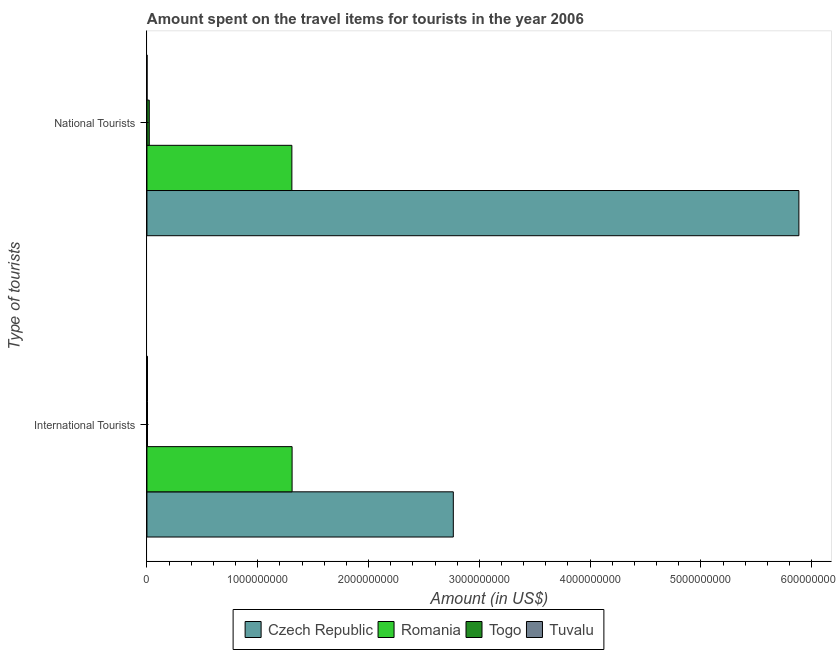How many different coloured bars are there?
Provide a short and direct response. 4. How many groups of bars are there?
Offer a very short reply. 2. What is the label of the 2nd group of bars from the top?
Offer a very short reply. International Tourists. What is the amount spent on travel items of international tourists in Czech Republic?
Provide a succinct answer. 2.76e+09. Across all countries, what is the maximum amount spent on travel items of national tourists?
Your answer should be very brief. 5.88e+09. Across all countries, what is the minimum amount spent on travel items of national tourists?
Give a very brief answer. 1.18e+06. In which country was the amount spent on travel items of national tourists maximum?
Make the answer very short. Czech Republic. In which country was the amount spent on travel items of national tourists minimum?
Provide a succinct answer. Tuvalu. What is the total amount spent on travel items of international tourists in the graph?
Your answer should be compact. 4.08e+09. What is the difference between the amount spent on travel items of national tourists in Tuvalu and that in Togo?
Your response must be concise. -1.98e+07. What is the difference between the amount spent on travel items of national tourists in Romania and the amount spent on travel items of international tourists in Czech Republic?
Provide a short and direct response. -1.46e+09. What is the average amount spent on travel items of national tourists per country?
Offer a terse response. 1.80e+09. What is the difference between the amount spent on travel items of international tourists and amount spent on travel items of national tourists in Togo?
Offer a very short reply. -1.60e+07. In how many countries, is the amount spent on travel items of national tourists greater than 200000000 US$?
Offer a terse response. 2. What is the ratio of the amount spent on travel items of national tourists in Czech Republic to that in Romania?
Make the answer very short. 4.5. Is the amount spent on travel items of national tourists in Togo less than that in Romania?
Keep it short and to the point. Yes. In how many countries, is the amount spent on travel items of international tourists greater than the average amount spent on travel items of international tourists taken over all countries?
Ensure brevity in your answer.  2. What does the 4th bar from the top in International Tourists represents?
Offer a terse response. Czech Republic. What does the 3rd bar from the bottom in National Tourists represents?
Provide a succinct answer. Togo. Are all the bars in the graph horizontal?
Your answer should be compact. Yes. Does the graph contain grids?
Provide a short and direct response. No. Where does the legend appear in the graph?
Your response must be concise. Bottom center. How many legend labels are there?
Your answer should be very brief. 4. What is the title of the graph?
Provide a succinct answer. Amount spent on the travel items for tourists in the year 2006. Does "Albania" appear as one of the legend labels in the graph?
Make the answer very short. No. What is the label or title of the Y-axis?
Offer a terse response. Type of tourists. What is the Amount (in US$) of Czech Republic in International Tourists?
Provide a short and direct response. 2.76e+09. What is the Amount (in US$) in Romania in International Tourists?
Provide a succinct answer. 1.31e+09. What is the Amount (in US$) of Tuvalu in International Tourists?
Provide a succinct answer. 4.96e+06. What is the Amount (in US$) of Czech Republic in National Tourists?
Your response must be concise. 5.88e+09. What is the Amount (in US$) of Romania in National Tourists?
Your answer should be compact. 1.31e+09. What is the Amount (in US$) in Togo in National Tourists?
Offer a very short reply. 2.10e+07. What is the Amount (in US$) of Tuvalu in National Tourists?
Provide a succinct answer. 1.18e+06. Across all Type of tourists, what is the maximum Amount (in US$) of Czech Republic?
Provide a short and direct response. 5.88e+09. Across all Type of tourists, what is the maximum Amount (in US$) in Romania?
Make the answer very short. 1.31e+09. Across all Type of tourists, what is the maximum Amount (in US$) of Togo?
Your response must be concise. 2.10e+07. Across all Type of tourists, what is the maximum Amount (in US$) of Tuvalu?
Offer a terse response. 4.96e+06. Across all Type of tourists, what is the minimum Amount (in US$) in Czech Republic?
Make the answer very short. 2.76e+09. Across all Type of tourists, what is the minimum Amount (in US$) in Romania?
Provide a succinct answer. 1.31e+09. Across all Type of tourists, what is the minimum Amount (in US$) of Tuvalu?
Ensure brevity in your answer.  1.18e+06. What is the total Amount (in US$) in Czech Republic in the graph?
Keep it short and to the point. 8.65e+09. What is the total Amount (in US$) of Romania in the graph?
Ensure brevity in your answer.  2.62e+09. What is the total Amount (in US$) in Togo in the graph?
Your answer should be compact. 2.60e+07. What is the total Amount (in US$) in Tuvalu in the graph?
Your answer should be compact. 6.14e+06. What is the difference between the Amount (in US$) of Czech Republic in International Tourists and that in National Tourists?
Keep it short and to the point. -3.12e+09. What is the difference between the Amount (in US$) of Romania in International Tourists and that in National Tourists?
Provide a succinct answer. 2.00e+06. What is the difference between the Amount (in US$) in Togo in International Tourists and that in National Tourists?
Your answer should be compact. -1.60e+07. What is the difference between the Amount (in US$) of Tuvalu in International Tourists and that in National Tourists?
Your answer should be very brief. 3.78e+06. What is the difference between the Amount (in US$) of Czech Republic in International Tourists and the Amount (in US$) of Romania in National Tourists?
Offer a terse response. 1.46e+09. What is the difference between the Amount (in US$) of Czech Republic in International Tourists and the Amount (in US$) of Togo in National Tourists?
Provide a short and direct response. 2.74e+09. What is the difference between the Amount (in US$) of Czech Republic in International Tourists and the Amount (in US$) of Tuvalu in National Tourists?
Give a very brief answer. 2.76e+09. What is the difference between the Amount (in US$) of Romania in International Tourists and the Amount (in US$) of Togo in National Tourists?
Offer a very short reply. 1.29e+09. What is the difference between the Amount (in US$) in Romania in International Tourists and the Amount (in US$) in Tuvalu in National Tourists?
Give a very brief answer. 1.31e+09. What is the difference between the Amount (in US$) in Togo in International Tourists and the Amount (in US$) in Tuvalu in National Tourists?
Keep it short and to the point. 3.82e+06. What is the average Amount (in US$) of Czech Republic per Type of tourists?
Your answer should be compact. 4.32e+09. What is the average Amount (in US$) in Romania per Type of tourists?
Offer a very short reply. 1.31e+09. What is the average Amount (in US$) in Togo per Type of tourists?
Provide a short and direct response. 1.30e+07. What is the average Amount (in US$) in Tuvalu per Type of tourists?
Provide a succinct answer. 3.07e+06. What is the difference between the Amount (in US$) in Czech Republic and Amount (in US$) in Romania in International Tourists?
Provide a short and direct response. 1.46e+09. What is the difference between the Amount (in US$) in Czech Republic and Amount (in US$) in Togo in International Tourists?
Ensure brevity in your answer.  2.76e+09. What is the difference between the Amount (in US$) in Czech Republic and Amount (in US$) in Tuvalu in International Tourists?
Ensure brevity in your answer.  2.76e+09. What is the difference between the Amount (in US$) in Romania and Amount (in US$) in Togo in International Tourists?
Your response must be concise. 1.30e+09. What is the difference between the Amount (in US$) in Romania and Amount (in US$) in Tuvalu in International Tourists?
Keep it short and to the point. 1.31e+09. What is the difference between the Amount (in US$) in Czech Republic and Amount (in US$) in Romania in National Tourists?
Ensure brevity in your answer.  4.58e+09. What is the difference between the Amount (in US$) of Czech Republic and Amount (in US$) of Togo in National Tourists?
Your answer should be compact. 5.86e+09. What is the difference between the Amount (in US$) in Czech Republic and Amount (in US$) in Tuvalu in National Tourists?
Your answer should be very brief. 5.88e+09. What is the difference between the Amount (in US$) of Romania and Amount (in US$) of Togo in National Tourists?
Make the answer very short. 1.29e+09. What is the difference between the Amount (in US$) of Romania and Amount (in US$) of Tuvalu in National Tourists?
Your answer should be compact. 1.31e+09. What is the difference between the Amount (in US$) in Togo and Amount (in US$) in Tuvalu in National Tourists?
Your response must be concise. 1.98e+07. What is the ratio of the Amount (in US$) of Czech Republic in International Tourists to that in National Tourists?
Your response must be concise. 0.47. What is the ratio of the Amount (in US$) of Togo in International Tourists to that in National Tourists?
Offer a very short reply. 0.24. What is the ratio of the Amount (in US$) in Tuvalu in International Tourists to that in National Tourists?
Offer a very short reply. 4.2. What is the difference between the highest and the second highest Amount (in US$) of Czech Republic?
Provide a short and direct response. 3.12e+09. What is the difference between the highest and the second highest Amount (in US$) of Romania?
Offer a terse response. 2.00e+06. What is the difference between the highest and the second highest Amount (in US$) in Togo?
Make the answer very short. 1.60e+07. What is the difference between the highest and the second highest Amount (in US$) in Tuvalu?
Offer a terse response. 3.78e+06. What is the difference between the highest and the lowest Amount (in US$) of Czech Republic?
Provide a short and direct response. 3.12e+09. What is the difference between the highest and the lowest Amount (in US$) in Romania?
Your answer should be compact. 2.00e+06. What is the difference between the highest and the lowest Amount (in US$) of Togo?
Keep it short and to the point. 1.60e+07. What is the difference between the highest and the lowest Amount (in US$) in Tuvalu?
Your answer should be very brief. 3.78e+06. 